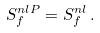<formula> <loc_0><loc_0><loc_500><loc_500>S _ { f } ^ { n l P } = S _ { f } ^ { n l } \, .</formula> 